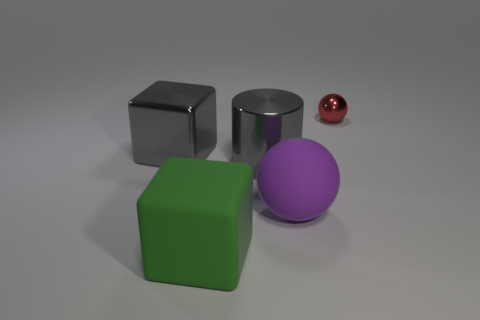Is the block on the left side of the green thing made of the same material as the big block that is right of the gray metallic cube?
Provide a short and direct response. No. Is the number of small balls in front of the metal ball less than the number of large gray rubber spheres?
Provide a short and direct response. No. There is a matte object that is left of the big ball; what color is it?
Your answer should be very brief. Green. There is a big thing in front of the ball to the left of the red thing; what is it made of?
Offer a terse response. Rubber. Are there any other red metallic balls that have the same size as the red sphere?
Offer a very short reply. No. How many objects are either metallic things that are on the left side of the large green rubber cube or large metal cubes left of the green block?
Keep it short and to the point. 1. Do the gray metal thing to the left of the gray metal cylinder and the ball in front of the red metallic ball have the same size?
Keep it short and to the point. Yes. There is a big gray thing on the left side of the cylinder; is there a small metal object that is on the left side of it?
Offer a very short reply. No. There is a small metal sphere; how many purple rubber spheres are right of it?
Your response must be concise. 0. What number of other things are there of the same color as the tiny ball?
Give a very brief answer. 0. 